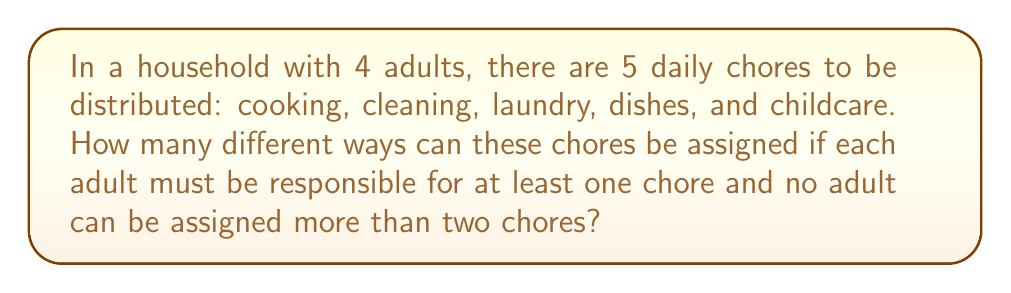Teach me how to tackle this problem. Let's approach this step-by-step using group theory concepts:

1) First, we need to consider the possible distributions of chores:
   - 1 adult gets 2 chores, 3 adults get 1 chore each
   - 2 adults get 2 chores each, 2 adults get 1 chore each

2) Let's calculate each case:

Case 1: 1 adult gets 2 chores, 3 adults get 1 chore each
   - Choose 1 adult to get 2 chores: $\binom{4}{1} = 4$ ways
   - Choose 2 chores for this adult: $\binom{5}{2} = 10$ ways
   - Assign the remaining 3 chores to the other 3 adults: $3!$ ways
   Total for Case 1: $4 \times 10 \times 3! = 240$ ways

Case 2: 2 adults get 2 chores each, 2 adults get 1 chore each
   - Choose 2 adults to get 2 chores each: $\binom{4}{2} = 6$ ways
   - Choose 2 chores for the first of these adults: $\binom{5}{2} = 10$ ways
   - Choose 2 chores for the second of these adults from the remaining 3: $\binom{3}{2} = 3$ ways
   - Assign the remaining chore to one of the other 2 adults: $2$ ways
   Total for Case 2: $6 \times 10 \times 3 \times 2 = 360$ ways

3) The total number of permutations is the sum of both cases:

   $$240 + 360 = 600$$

Therefore, there are 600 different ways to distribute the chores equitably.
Answer: 600 permutations 